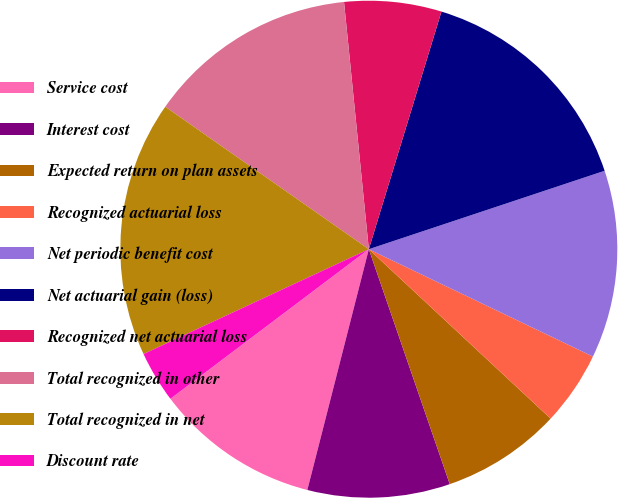<chart> <loc_0><loc_0><loc_500><loc_500><pie_chart><fcel>Service cost<fcel>Interest cost<fcel>Expected return on plan assets<fcel>Recognized actuarial loss<fcel>Net periodic benefit cost<fcel>Net actuarial gain (loss)<fcel>Recognized net actuarial loss<fcel>Total recognized in other<fcel>Total recognized in net<fcel>Discount rate<nl><fcel>10.74%<fcel>9.26%<fcel>7.78%<fcel>4.83%<fcel>12.22%<fcel>15.17%<fcel>6.31%<fcel>13.69%<fcel>16.65%<fcel>3.35%<nl></chart> 